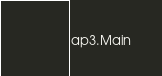Convert code to text. <code><loc_0><loc_0><loc_500><loc_500><_Rust_>ap3.Main
</code> 